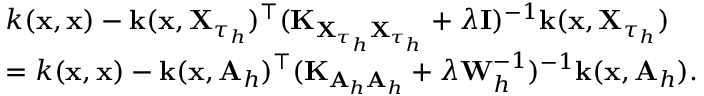Convert formula to latex. <formula><loc_0><loc_0><loc_500><loc_500>\begin{array} { r l } & { k ( x , x ) - k ( x , X _ { \tau _ { h } } ) ^ { \top } ( K _ { X _ { \tau _ { h } } X _ { \tau _ { h } } } + \lambda I ) ^ { - 1 } k ( x , X _ { \tau _ { h } } ) } \\ & { = k ( x , x ) - k ( x , A _ { h } ) ^ { \top } ( K _ { A _ { h } A _ { h } } + \lambda W _ { h } ^ { - 1 } ) ^ { - 1 } k ( x , A _ { h } ) . } \end{array}</formula> 